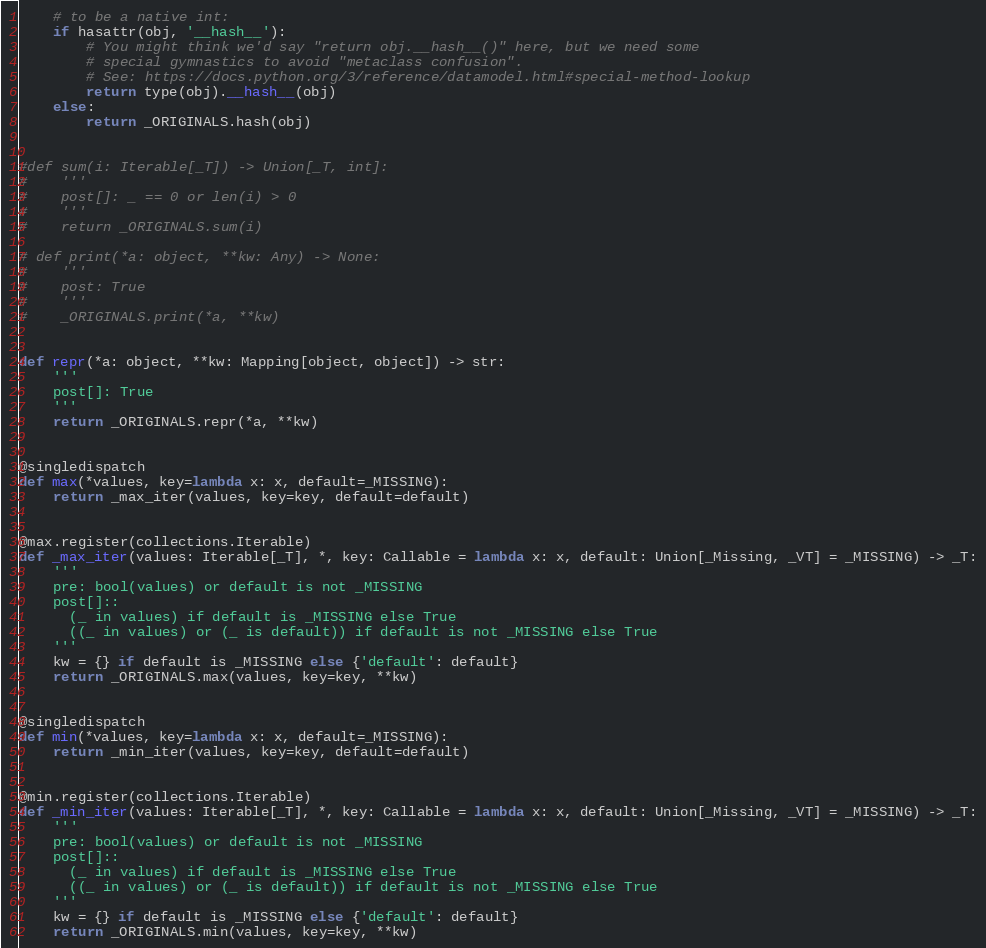Convert code to text. <code><loc_0><loc_0><loc_500><loc_500><_Python_>    # to be a native int:
    if hasattr(obj, '__hash__'):
        # You might think we'd say "return obj.__hash__()" here, but we need some
        # special gymnastics to avoid "metaclass confusion".
        # See: https://docs.python.org/3/reference/datamodel.html#special-method-lookup
        return type(obj).__hash__(obj)
    else:
        return _ORIGINALS.hash(obj)


#def sum(i: Iterable[_T]) -> Union[_T, int]:
#    '''
#    post[]: _ == 0 or len(i) > 0
#    '''
#    return _ORIGINALS.sum(i)

# def print(*a: object, **kw: Any) -> None:
#    '''
#    post: True
#    '''
#    _ORIGINALS.print(*a, **kw)


def repr(*a: object, **kw: Mapping[object, object]) -> str:
    '''
    post[]: True
    '''
    return _ORIGINALS.repr(*a, **kw)


@singledispatch
def max(*values, key=lambda x: x, default=_MISSING):
    return _max_iter(values, key=key, default=default)


@max.register(collections.Iterable)
def _max_iter(values: Iterable[_T], *, key: Callable = lambda x: x, default: Union[_Missing, _VT] = _MISSING) -> _T:
    '''
    pre: bool(values) or default is not _MISSING
    post[]::
      (_ in values) if default is _MISSING else True
      ((_ in values) or (_ is default)) if default is not _MISSING else True
    '''
    kw = {} if default is _MISSING else {'default': default}
    return _ORIGINALS.max(values, key=key, **kw)


@singledispatch
def min(*values, key=lambda x: x, default=_MISSING):
    return _min_iter(values, key=key, default=default)


@min.register(collections.Iterable)
def _min_iter(values: Iterable[_T], *, key: Callable = lambda x: x, default: Union[_Missing, _VT] = _MISSING) -> _T:
    '''
    pre: bool(values) or default is not _MISSING
    post[]::
      (_ in values) if default is _MISSING else True
      ((_ in values) or (_ is default)) if default is not _MISSING else True
    '''
    kw = {} if default is _MISSING else {'default': default}
    return _ORIGINALS.min(values, key=key, **kw)
</code> 